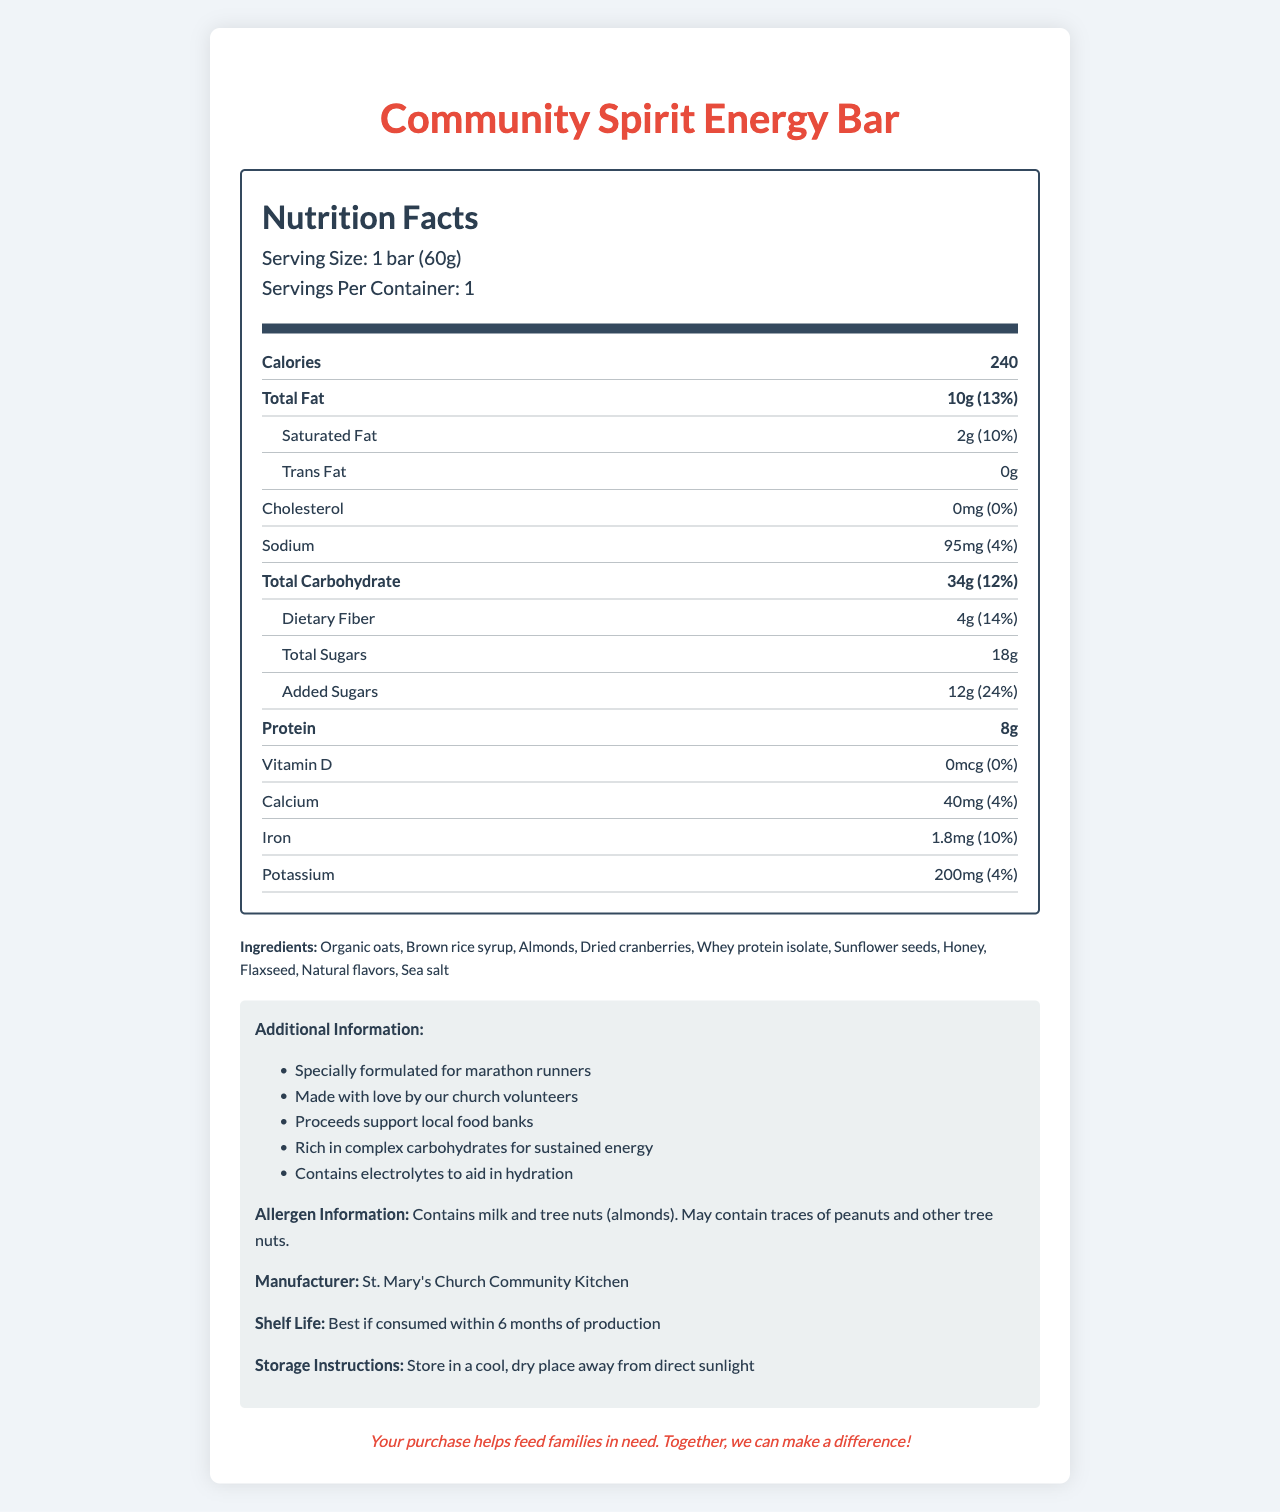What is the serving size of the Community Spirit Energy Bar? The nutrition label clearly states that the serving size is 1 bar (60g).
Answer: 1 bar (60g) How many calories are there in one serving of the Community Spirit Energy Bar? Under "Nutrition Facts", it specifies there are 240 calories per serving.
Answer: 240 calories What are the total fats per serving in the Community Spirit Energy Bar? The label indicates "Total Fat" as 10g per serving.
Answer: 10g How much protein does the Community Spirit Energy Bar contain? The label lists the protein content directly as 8g per serving.
Answer: 8g What are the main ingredients in the Community Spirit Energy Bar? The main ingredients are listed in the "Ingredients" section.
Answer: Organic oats, Brown rice syrup, Almonds, Dried cranberries, Whey protein isolate, Sunflower seeds, Honey, Flaxseed, Natural flavors, Sea salt Which allergen is mentioned in the Community Spirit Energy Bar? A. Soy B. Tree nuts C. Wheat The allergen information states that the product "Contains milk and tree nuts (almonds)."
Answer: B. Tree nuts What is the daily value percentage of dietary fiber in one serving? A. 10% B. 12% C. 14% The label states that the dietary fiber is 4g, which is 14% of the daily value.
Answer: C. 14% Is there any trans fat in the Community Spirit Energy Bar? The label specifically states there is 0g of trans fat per serving.
Answer: No What is the purpose of the proceeds from the Community Spirit Energy Bar sales? The document mentions "Proceeds support local food banks" in the additional information section.
Answer: Proceeds support local food banks Describe the main features and purpose of the Community Spirit Energy Bar. The document details the nutritional content, ingredients, additional information related to allergens, manufacturer, and the charity cause supported by the sale of the Community Spirit Energy Bar.
Answer: The Community Spirit Energy Bar is an energy bar designed for marathon runners, made with organic oats, and other natural ingredients; it contains essential electrolytes for hydration. It provides 240 calories per serving, with significant amounts of protein and dietary fiber but no trans fat or cholesterol. It's manufactured by St. Mary's Church Community Kitchen, and proceeds from its sales support local food banks. It also includes allergen information, storage instructions, and a charity statement about feeding families in need. What is the production date of the Community Spirit Energy Bar? The document does not provide the specific production date.
Answer: Not enough information What are the benefits mentioned for marathon runners in the covered document? The additional information section specifies these benefits for marathon runners.
Answer: Rich in complex carbohydrates for sustained energy, contains electrolytes to aid in hydration How much sodium is in one serving of the Community Spirit Energy Bar? The label lists the sodium content as 95mg per serving.
Answer: 95mg What is the shelf life of the Community Spirit Energy Bar? The document provides this information under "Additional Information".
Answer: Best if consumed within 6 months of production How much added sugar is there in one serving? The nutrition label indicates that there are 12g of added sugars per serving.
Answer: 12g 